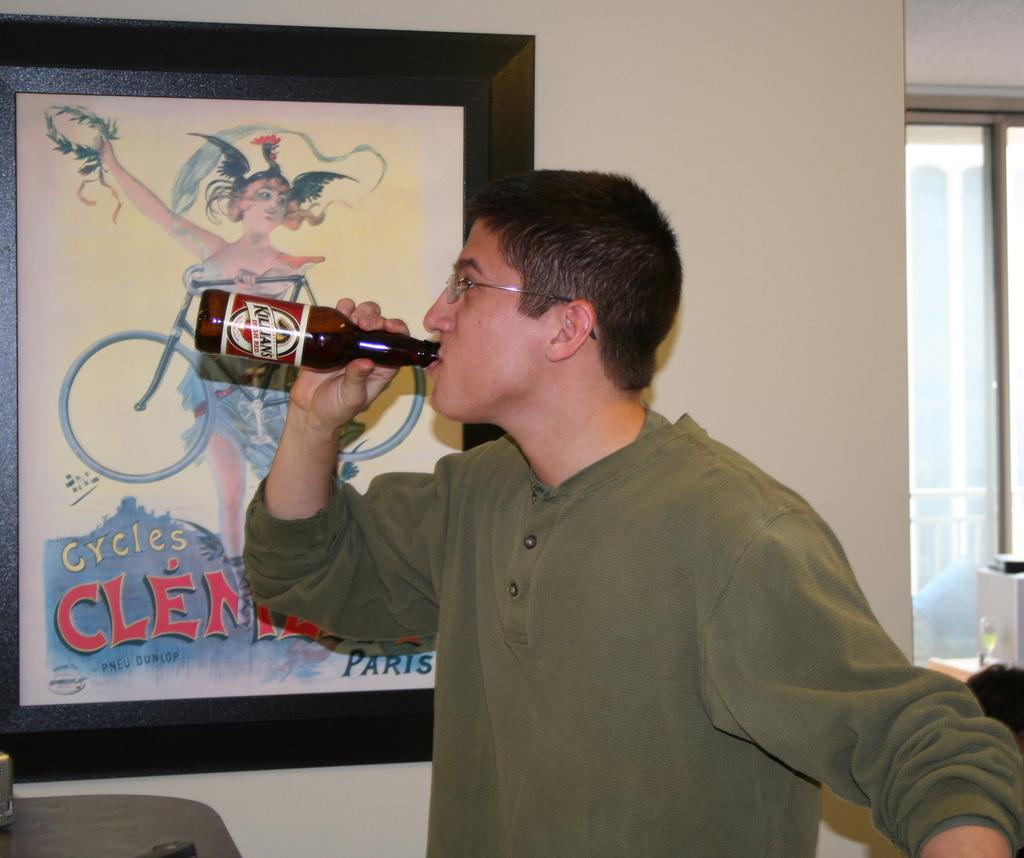Who or what is present in the image? There is a person in the image. What is the person holding in the image? The person is holding a bottle. What other object can be seen in the image? There is a frame in the image. Where is the frame located in relation to the person? The frame is beside the person. What type of dress is the person wearing in the image? There is no information about the person's clothing in the provided facts, so we cannot determine if they are wearing a dress or any other type of clothing. 